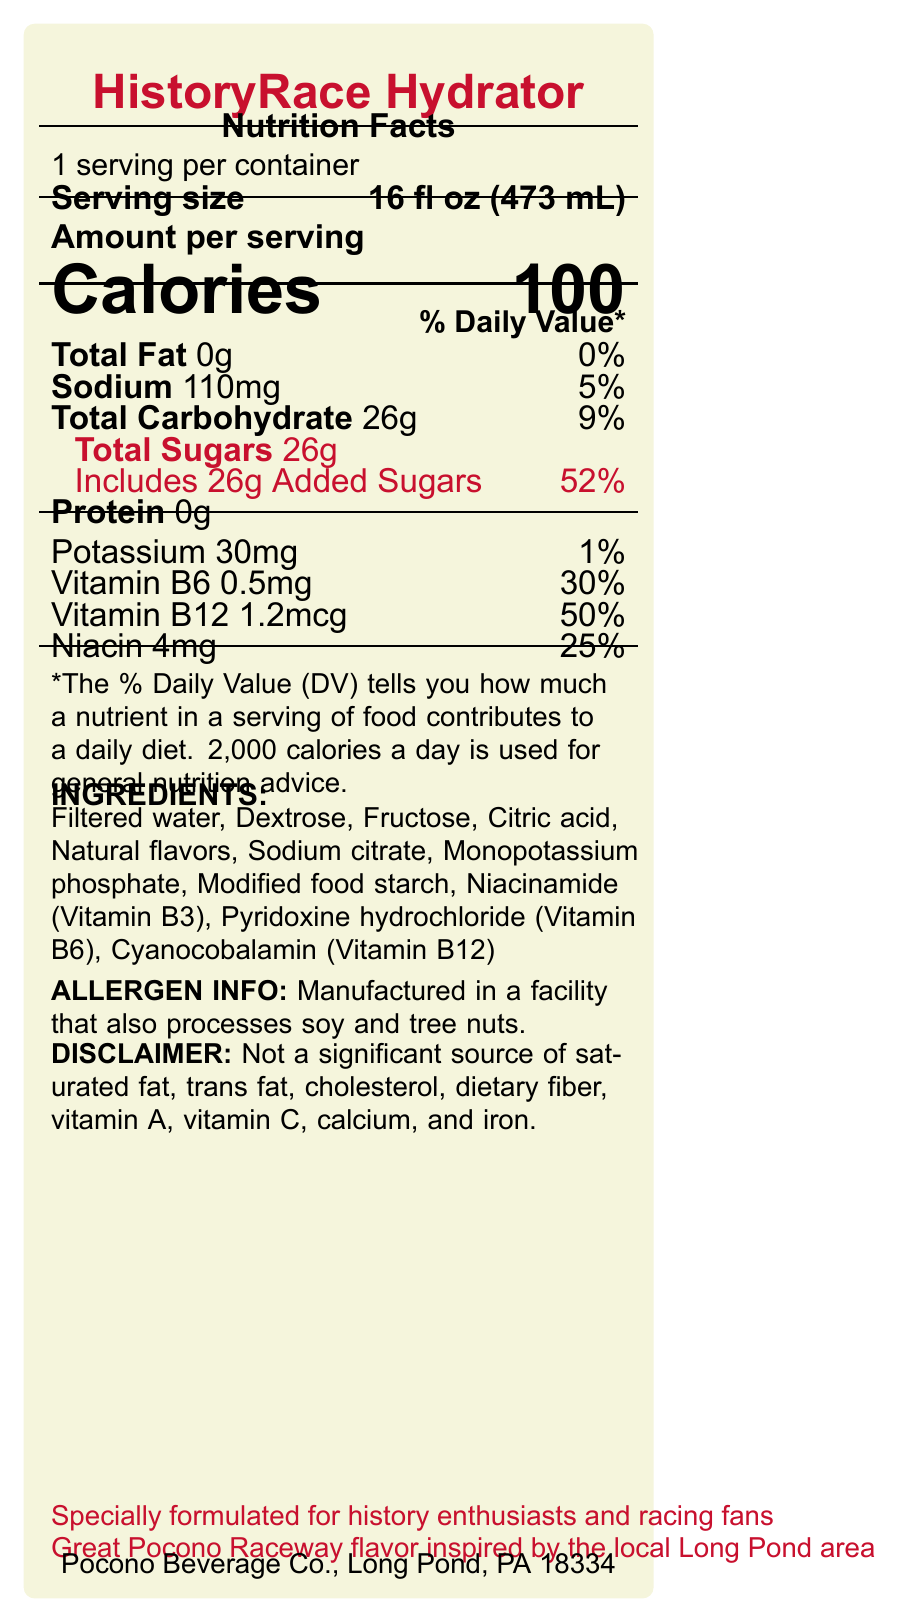What is the serving size of HistoryRace Hydrator? The serving size is listed as "16 fl oz (473 mL)" at the top of the Nutrition Facts section.
Answer: 16 fl oz (473 mL) How many calories are in one serving of HistoryRace Hydrator? The document specifies "Calories 100" in the Amount per serving section.
Answer: 100 What percentage of the Daily Value is the sodium content? The sodium content is given as 110mg, which is 5% of the Daily Value.
Answer: 5% What are the total sugars in one serving, and how much of this is added sugars? The label shows "Total Sugars 26g" and "Includes 26g Added Sugars".
Answer: 26g total sugars, 26g added sugars What are the key vitamins included in HistoryRace Hydrator? The document lists Vitamin B6 (0.5mg, 30% DV), Vitamin B12 (1.2mcg, 50% DV), and Niacin (4mg, 25% DV) as part of the nutritional content.
Answer: Vitamin B6, Vitamin B12, Niacin Which ingredient is NOT listed on the label? A. Dextrose B. Fructose C. Aspartame D. Citric Acid Aspartame is not listed among the ingredients, while the others are.
Answer: C. Aspartame How much protein does one serving contain? A. 0g B. 1g C. 5g D. 10g The protein content per serving is listed as 0g.
Answer: A. 0g Does this product contain any allergens? It is stated that the product is manufactured in a facility that processes soy and tree nuts, which are common allergens.
Answer: Yes Does HistoryRace Hydrator provide a significant source of dietary fiber? The disclaimer clearly mentions that the product is not a significant source of dietary fiber.
Answer: No Summarize the main features of HistoryRace Hydrator based on the document. The summary reflects the product's name, target audience, nutrient contents, and specific claims made in the document.
Answer: HistoryRace Hydrator is a sports drink designed for history buffs and race fans, providing hydration and nutrients like B vitamins for mental focus. Each 16 fl oz serving has 100 calories, 0g total fat, 110mg sodium, 26g total sugars (all added), and key electrolytes such as potassium. It includes vitamins B6, B12, and Niacin, and is formulated to replace electrolytes and support mental focus. Additionally, it is manufactured in a facility that processes soy and tree nuts and claims to have a Great Pocono Raceway-inspired flavor. What is the flavor inspiration behind HistoryRace Hydrator? The marketing claims section indicates that the flavor is inspired by the local Great Pocono Raceway.
Answer: Great Pocono Raceway Where is the manufacturer of HistoryRace Hydrator located? The manufacturer information states, "Pocono Beverage Co., Long Pond, PA 18334."
Answer: Long Pond, PA 18334 What is the percentage of the Daily Value for added sugars in the product? The document indicates that the added sugars per serving is 26g, which is 52% of the Daily Value.
Answer: 52% Can you determine the exact quantity of calcium in HistoryRace Hydrator? The document states that the product is not a significant source of calcium, but does not provide exact quantities.
Answer: Cannot be determined 